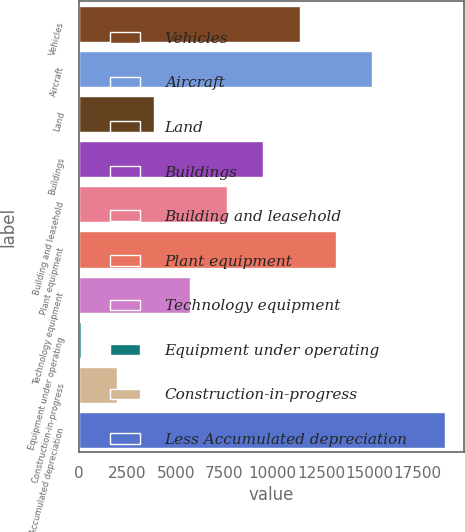Convert chart to OTSL. <chart><loc_0><loc_0><loc_500><loc_500><bar_chart><fcel>Vehicles<fcel>Aircraft<fcel>Land<fcel>Buildings<fcel>Building and leasehold<fcel>Plant equipment<fcel>Technology equipment<fcel>Equipment under operating<fcel>Construction-in-progress<fcel>Less Accumulated depreciation<nl><fcel>11389.2<fcel>15154.6<fcel>3858.4<fcel>9506.5<fcel>7623.8<fcel>13271.9<fcel>5741.1<fcel>93<fcel>1975.7<fcel>18920<nl></chart> 